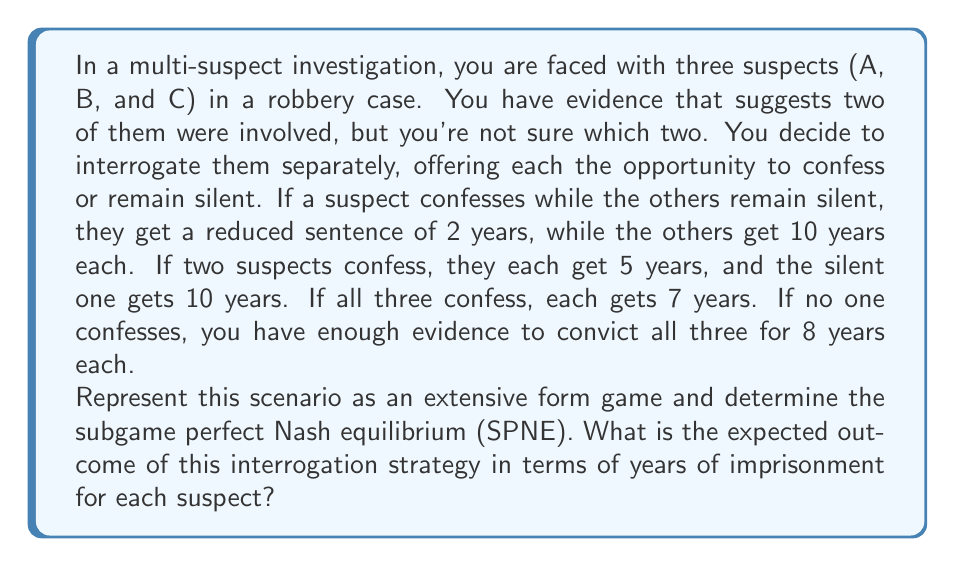Provide a solution to this math problem. To solve this problem, we need to follow these steps:

1) First, let's represent the game in extensive form. Since there are three players with two choices each, we have $2^3 = 8$ possible outcomes.

2) We can represent the payoffs (in negative years of imprisonment) as follows:

   $$(A, B, C)$$
   Confess, Confess, Confess: $(-7, -7, -7)$
   Confess, Confess, Silent: $(-5, -5, -10)$
   Confess, Silent, Confess: $(-5, -10, -5)$
   Silent, Confess, Confess: $(-10, -5, -5)$
   Confess, Silent, Silent: $(-2, -10, -10)$
   Silent, Confess, Silent: $(-10, -2, -10)$
   Silent, Silent, Confess: $(-10, -10, -2)$
   Silent, Silent, Silent: $(-8, -8, -8)$

3) To find the subgame perfect Nash equilibrium, we use backward induction. We start from the end of the game tree and work our way back.

4) For each suspect, confessing is a dominant strategy:
   - If the other two confess, confessing gives -7 years instead of -10.
   - If one other confesses and one is silent, confessing gives -5 years instead of -10.
   - If both others are silent, confessing gives -2 years instead of -8.

5) Therefore, the unique SPNE is (Confess, Confess, Confess).

6) In this equilibrium, each suspect will serve 7 years in prison.
Answer: The subgame perfect Nash equilibrium is (Confess, Confess, Confess), resulting in each suspect serving 7 years in prison. 